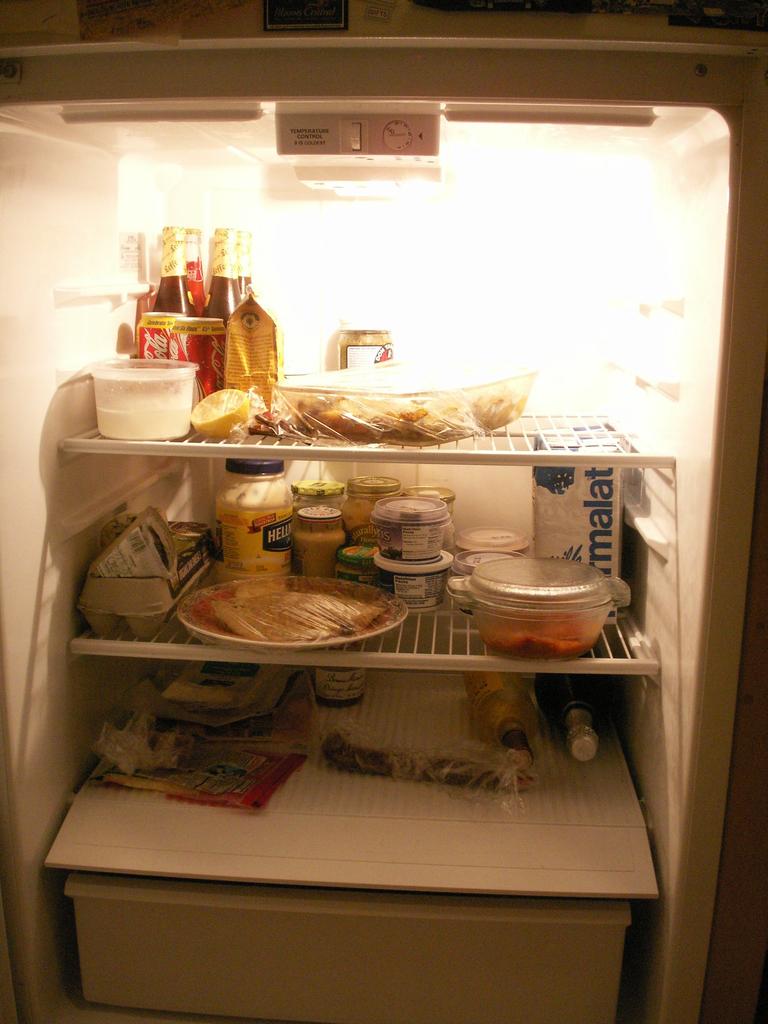What brand of mayonnaise is in the refrigerator?
Ensure brevity in your answer.  Hellmans. What is on the white box?
Ensure brevity in your answer.  Malat. 